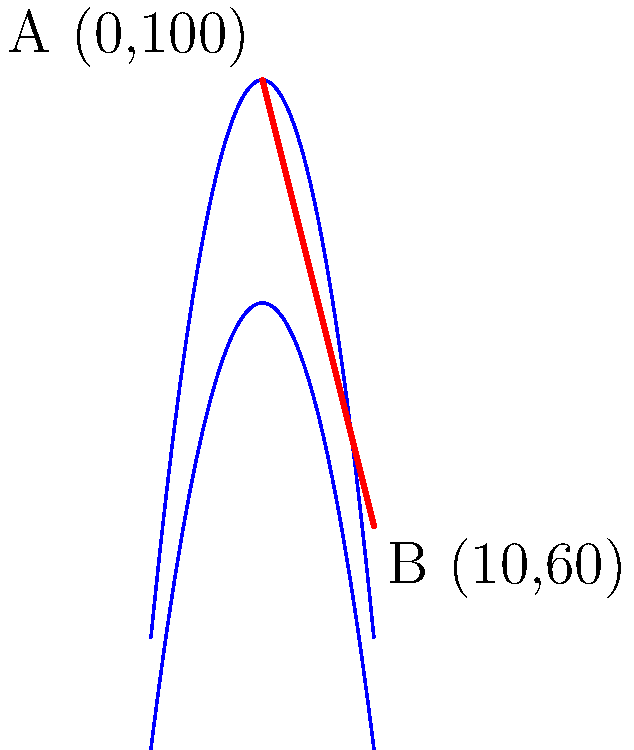A new ski run is planned for the Cedar Mountains in Lebanon. The terrain contours are shown in the diagram above. If the ski run starts at point A (0,100) and ends at point B (10,60), what is the optimal slope angle for the ski run? (Assume the optimal slope angle for intermediate skiers is between 25° and 35°) To calculate the optimal slope angle for the ski run, we need to follow these steps:

1. Calculate the horizontal distance:
   $\Delta x = 10 - 0 = 10$ m

2. Calculate the vertical drop:
   $\Delta y = 100 - 60 = 40$ m

3. Calculate the slope angle using the arctangent function:
   $\theta = \arctan(\frac{\Delta y}{\Delta x})$

4. Substitute the values:
   $\theta = \arctan(\frac{40}{10}) = \arctan(4)$

5. Calculate the result:
   $\theta \approx 21.8°$

6. Compare with the optimal range for intermediate skiers (25° to 35°):
   The calculated angle is less than the optimal range, so we need to increase it.

7. To achieve the minimum optimal angle of 25°, we can adjust the horizontal distance:
   $\tan(25°) = \frac{40}{x}$
   $x = \frac{40}{\tan(25°)} \approx 85.5$ m

8. Round to the nearest whole number:
   Optimal horizontal distance ≈ 86 m

Therefore, the optimal slope angle for the ski run would be 25°, achieved by extending the horizontal distance to 86 m.
Answer: 25° 